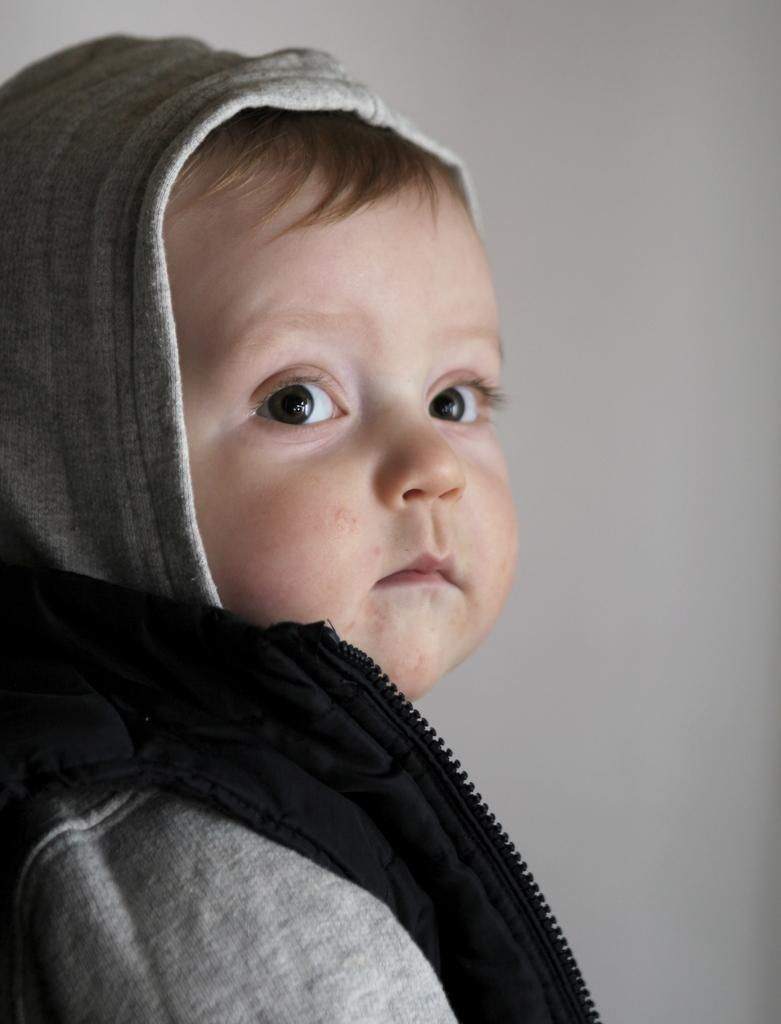What is the main subject of the image? There is a child in the image. What is the child wearing? The child is wearing a hoodie. What type of quarter is the child holding in the image? There is no quarter present in the image. What type of writing can be seen on the child's hoodie in the image? The image does not show any writing on the child's hoodie. 